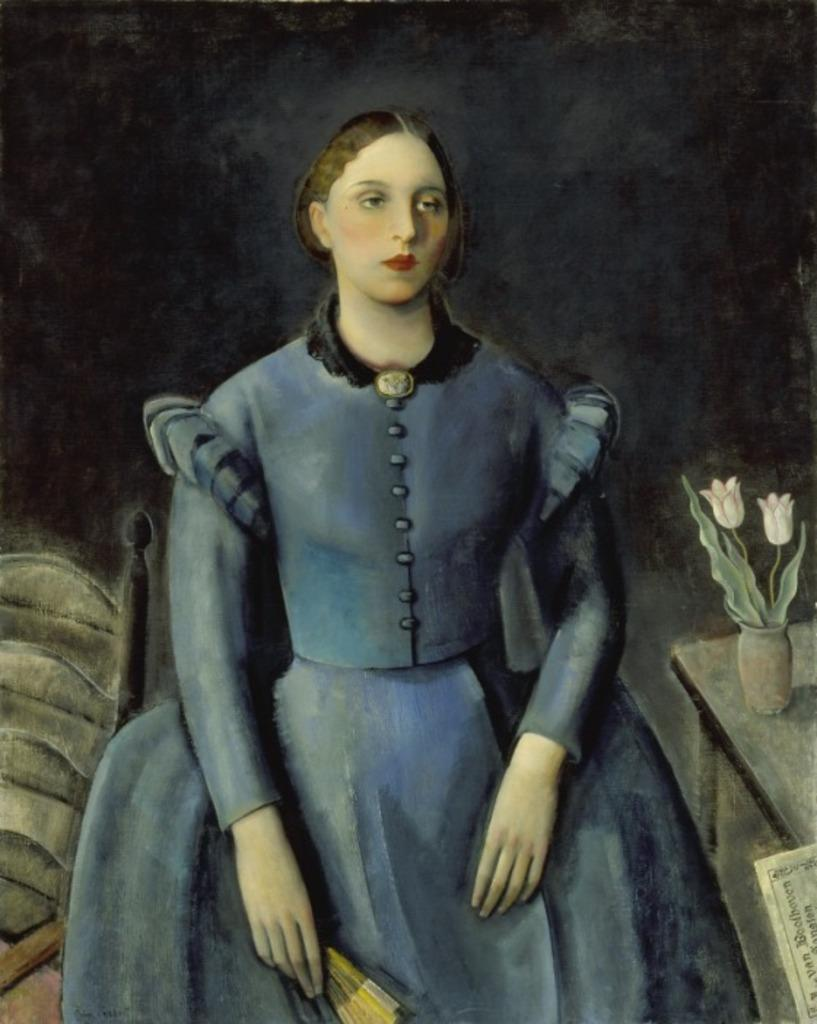What is depicted in the painting in the image? There is a painting of a lady in the image. What type of furniture is present in the image? There is a chair and a table in the image. What is placed on the table in the image? There is a flower vase on the table in the image. How does the lady in the painting breathe in the image? The lady in the painting does not breathe, as she is a two-dimensional representation in an artwork. 